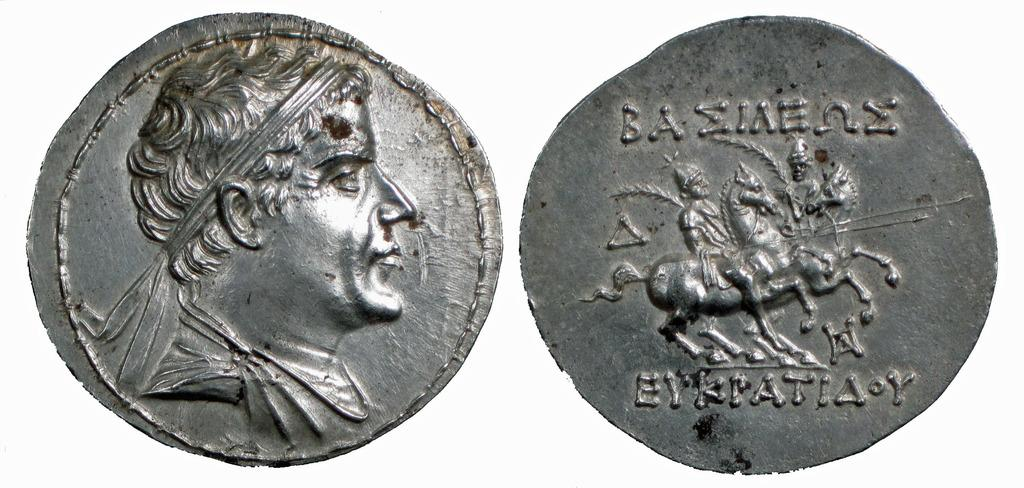<image>
Describe the image concisely. A very old silver colored coin with unknown writing on it. 